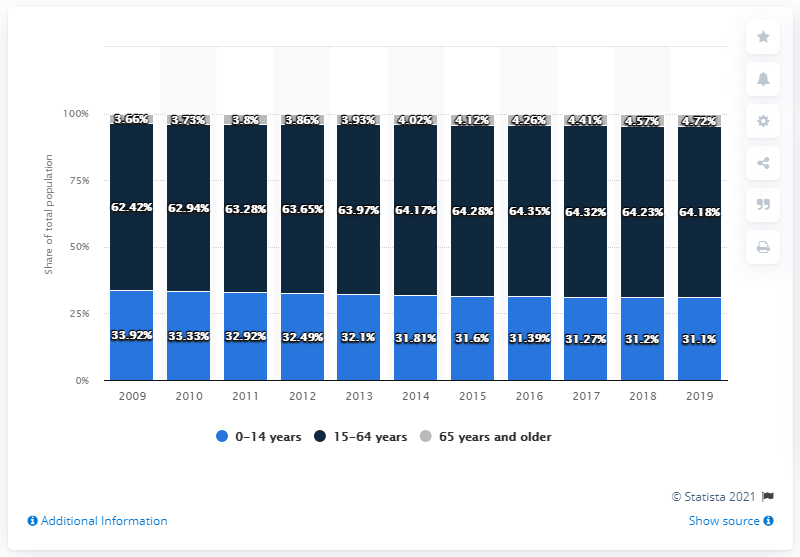Mention a couple of crucial points in this snapshot. In 2019, approximately 31.1% of Cambodia's population was aged 0 to 14 years old. 